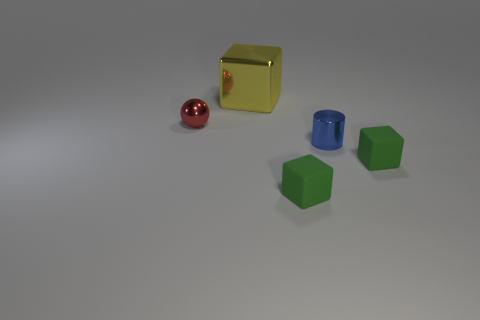Add 1 large yellow rubber balls. How many objects exist? 6 Subtract all red blocks. Subtract all red spheres. How many blocks are left? 3 Subtract all spheres. How many objects are left? 4 Add 2 yellow shiny objects. How many yellow shiny objects exist? 3 Subtract 0 cyan balls. How many objects are left? 5 Subtract all blocks. Subtract all big shiny things. How many objects are left? 1 Add 2 rubber cubes. How many rubber cubes are left? 4 